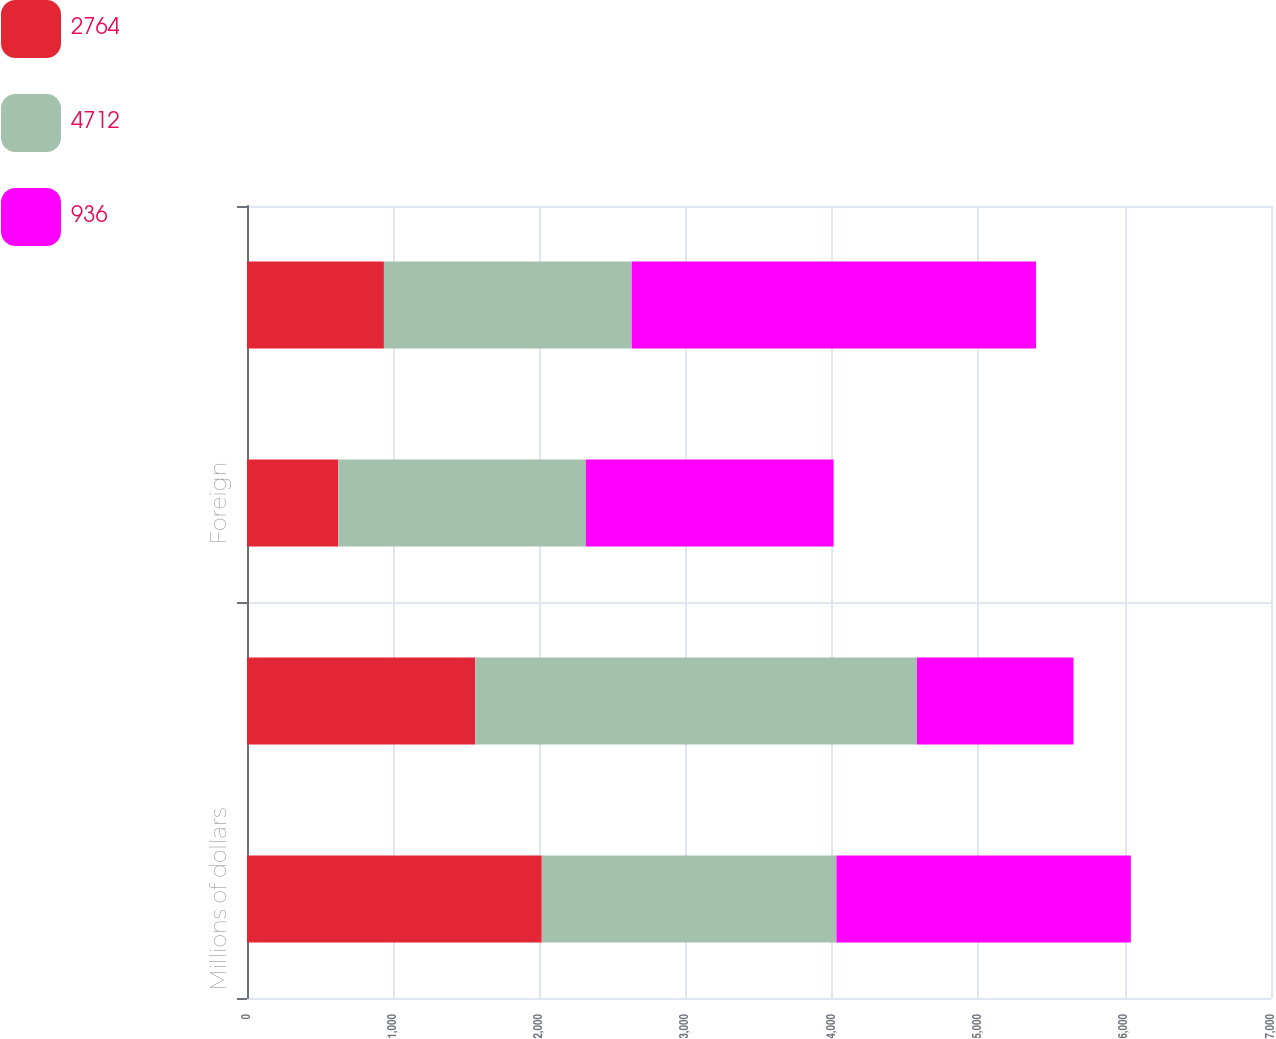<chart> <loc_0><loc_0><loc_500><loc_500><stacked_bar_chart><ecel><fcel>Millions of dollars<fcel>United States<fcel>Foreign<fcel>Total<nl><fcel>2764<fcel>2015<fcel>1560<fcel>624<fcel>936<nl><fcel>4712<fcel>2014<fcel>3020<fcel>1692<fcel>1694<nl><fcel>936<fcel>2013<fcel>1070<fcel>1694<fcel>2764<nl></chart> 